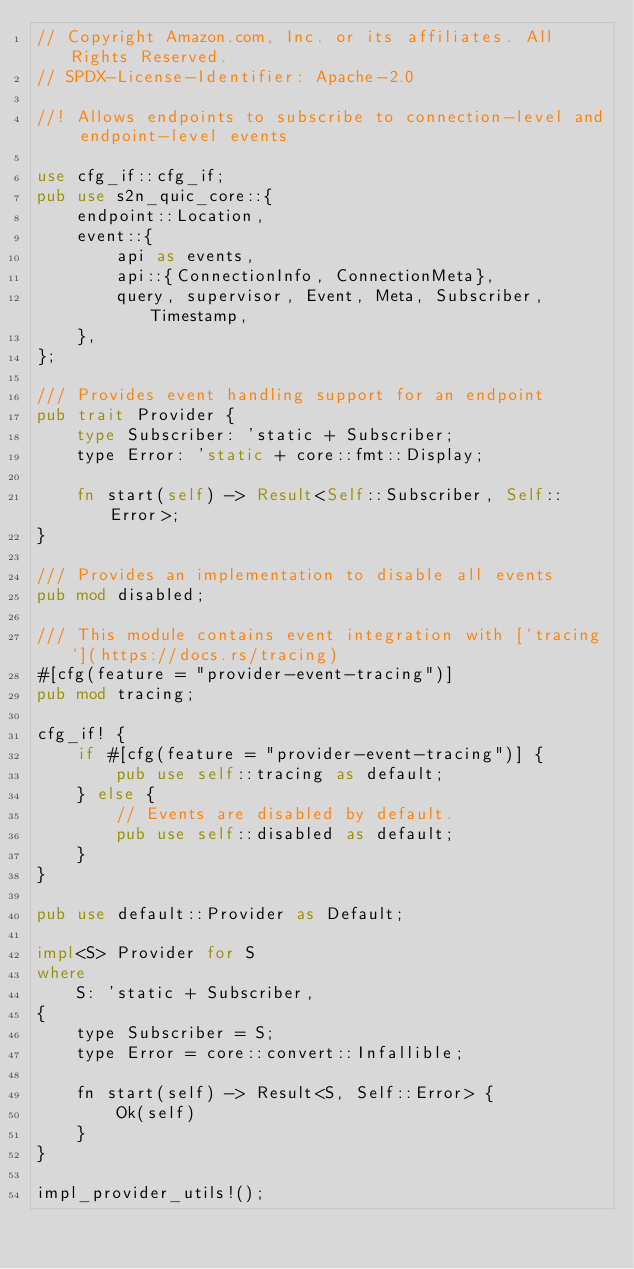<code> <loc_0><loc_0><loc_500><loc_500><_Rust_>// Copyright Amazon.com, Inc. or its affiliates. All Rights Reserved.
// SPDX-License-Identifier: Apache-2.0

//! Allows endpoints to subscribe to connection-level and endpoint-level events

use cfg_if::cfg_if;
pub use s2n_quic_core::{
    endpoint::Location,
    event::{
        api as events,
        api::{ConnectionInfo, ConnectionMeta},
        query, supervisor, Event, Meta, Subscriber, Timestamp,
    },
};

/// Provides event handling support for an endpoint
pub trait Provider {
    type Subscriber: 'static + Subscriber;
    type Error: 'static + core::fmt::Display;

    fn start(self) -> Result<Self::Subscriber, Self::Error>;
}

/// Provides an implementation to disable all events
pub mod disabled;

/// This module contains event integration with [`tracing`](https://docs.rs/tracing)
#[cfg(feature = "provider-event-tracing")]
pub mod tracing;

cfg_if! {
    if #[cfg(feature = "provider-event-tracing")] {
        pub use self::tracing as default;
    } else {
        // Events are disabled by default.
        pub use self::disabled as default;
    }
}

pub use default::Provider as Default;

impl<S> Provider for S
where
    S: 'static + Subscriber,
{
    type Subscriber = S;
    type Error = core::convert::Infallible;

    fn start(self) -> Result<S, Self::Error> {
        Ok(self)
    }
}

impl_provider_utils!();
</code> 